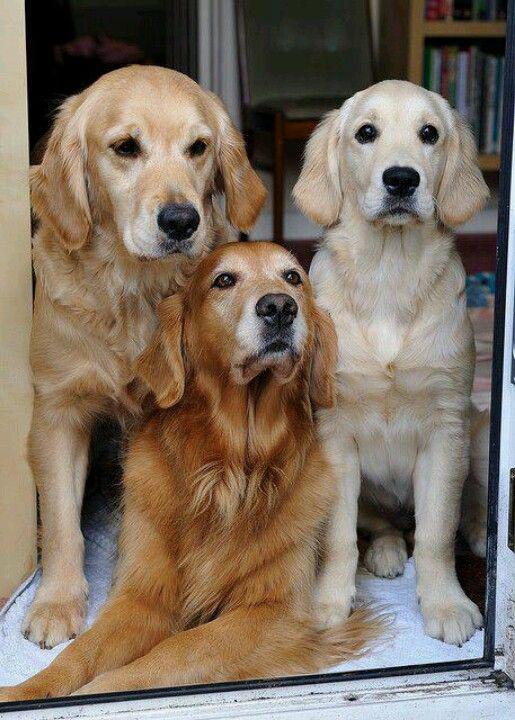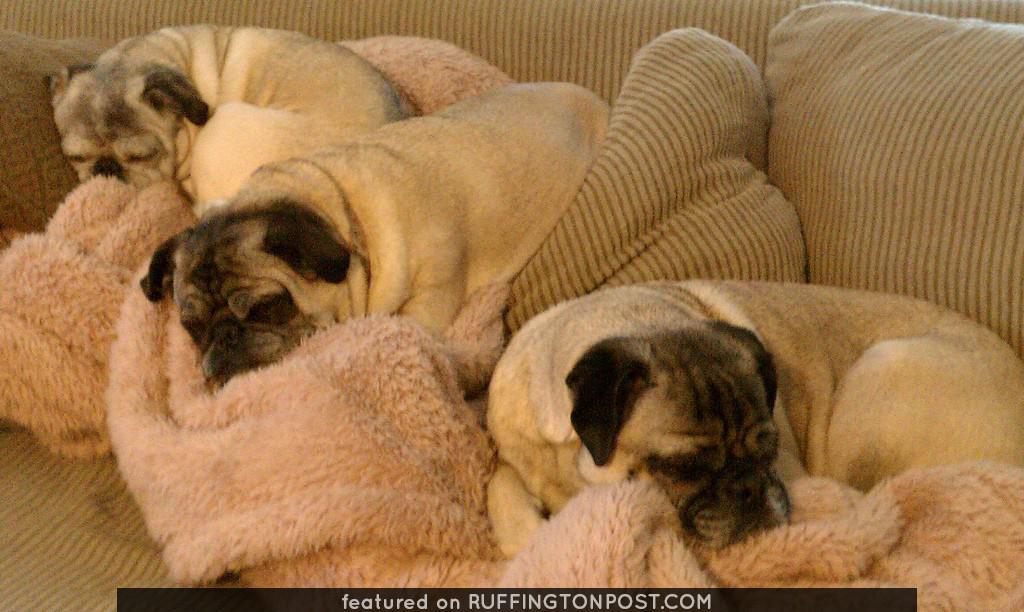The first image is the image on the left, the second image is the image on the right. For the images shown, is this caption "An image contains three pug dogs on a wooden picnic table." true? Answer yes or no. No. The first image is the image on the left, the second image is the image on the right. Assess this claim about the two images: "Three dogs are on a wooden step in one of the images.". Correct or not? Answer yes or no. No. 